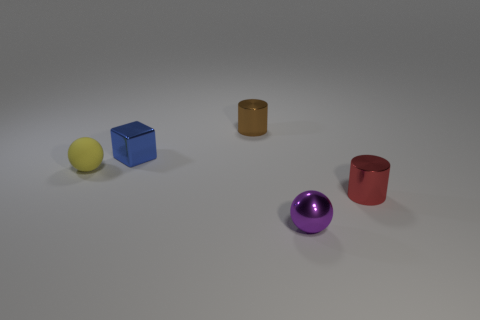Does the purple sphere that is in front of the blue metallic object have the same size as the yellow matte object?
Ensure brevity in your answer.  Yes. What is the shape of the tiny brown metallic thing behind the tiny shiny thing right of the small purple metallic sphere?
Provide a short and direct response. Cylinder. There is a thing that is in front of the cylinder in front of the yellow object; what is its size?
Your answer should be compact. Small. The small sphere that is left of the brown metallic cylinder is what color?
Provide a succinct answer. Yellow. What is the size of the red thing that is made of the same material as the purple ball?
Make the answer very short. Small. How many tiny red shiny things are the same shape as the tiny brown object?
Your answer should be compact. 1. There is a yellow ball that is the same size as the red metal cylinder; what is it made of?
Ensure brevity in your answer.  Rubber. Is there a small brown cylinder made of the same material as the yellow object?
Provide a short and direct response. No. There is a metallic object that is both right of the block and behind the rubber object; what is its color?
Make the answer very short. Brown. What is the material of the sphere on the left side of the tiny thing that is in front of the tiny thing on the right side of the small purple object?
Your response must be concise. Rubber. 